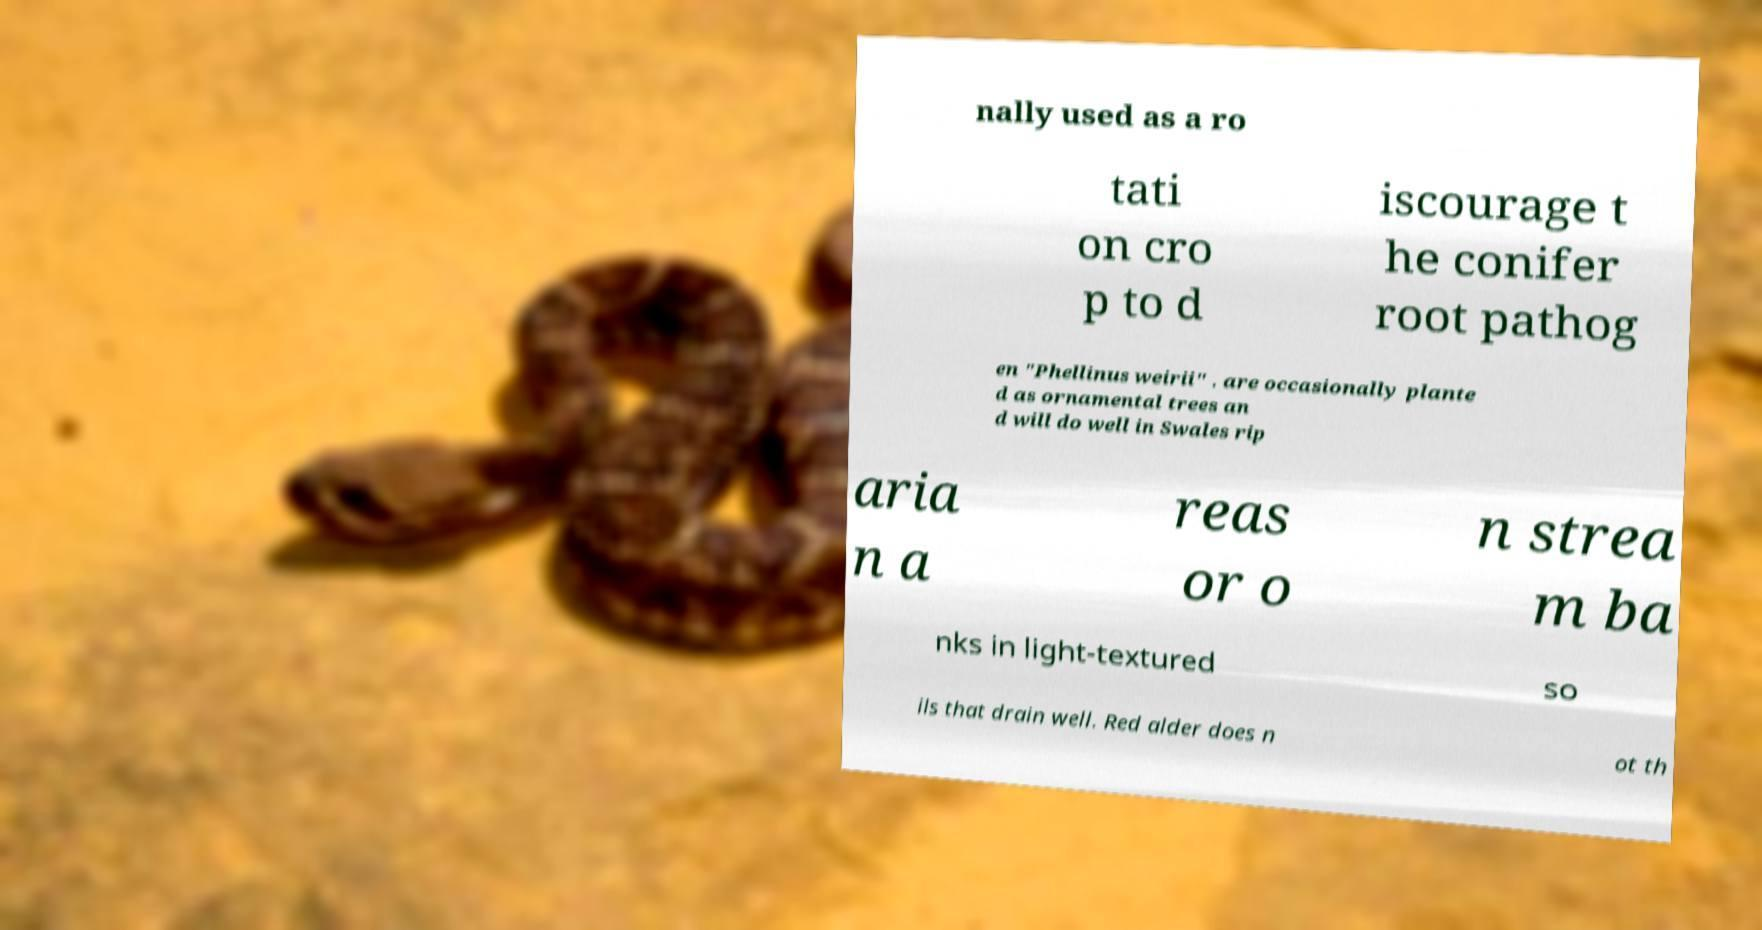Please read and relay the text visible in this image. What does it say? nally used as a ro tati on cro p to d iscourage t he conifer root pathog en "Phellinus weirii" . are occasionally plante d as ornamental trees an d will do well in Swales rip aria n a reas or o n strea m ba nks in light-textured so ils that drain well. Red alder does n ot th 